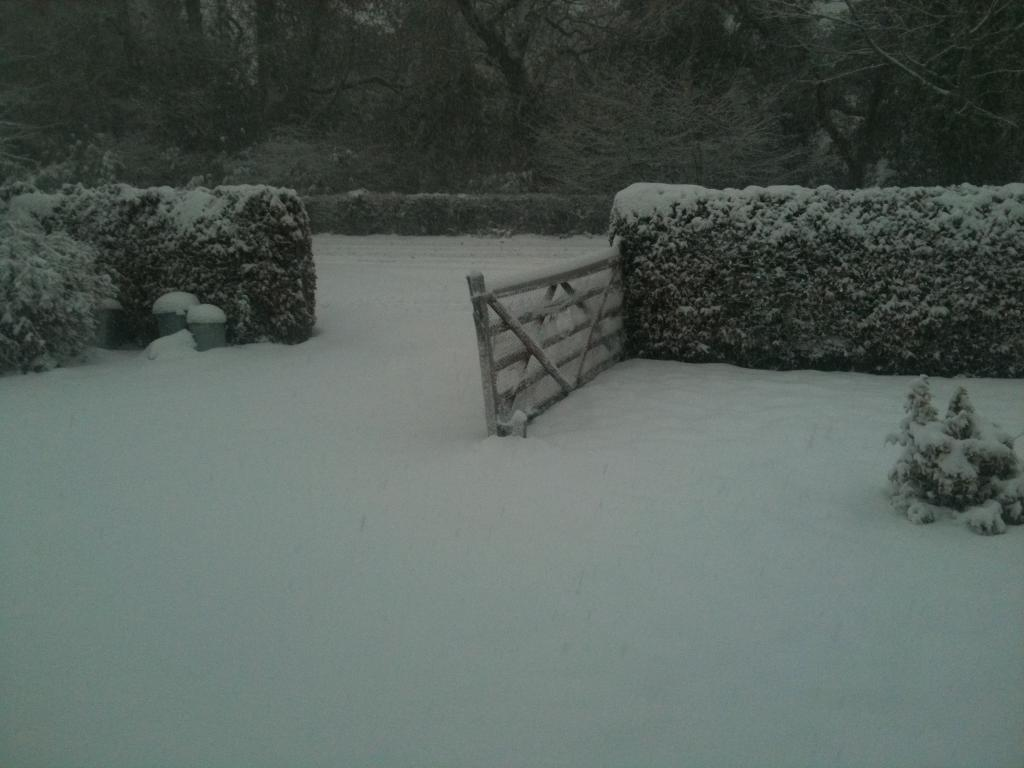What type of weather condition is depicted at the bottom of the image? There is snow at the bottom of the image, indicating a cold or wintry weather condition. What type of vegetation can be seen in the image? There are plants in the image. What architectural feature is located in the middle of the image? There is a gate in the middle of the image. What can be seen in the background of the image? There are trees visible in the background of the image. What type of eggnog is being served at the table in the image? There is no table or eggnog present in the image. Can you tell me how the plants are running in the image? The plants are not running in the image; they are stationary. 